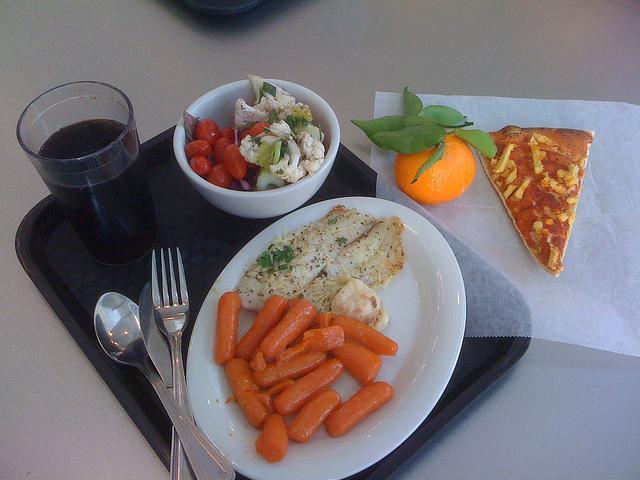How many carrots can be seen?
Give a very brief answer. 1. 